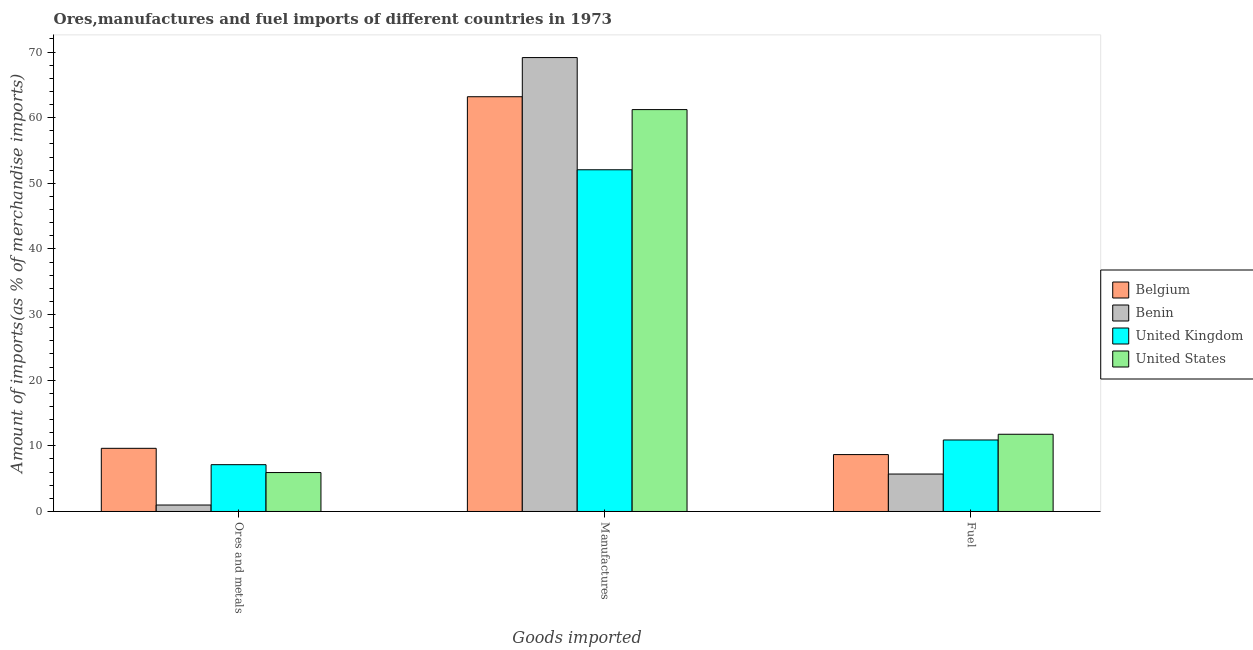How many groups of bars are there?
Offer a very short reply. 3. Are the number of bars on each tick of the X-axis equal?
Make the answer very short. Yes. How many bars are there on the 1st tick from the left?
Offer a terse response. 4. What is the label of the 3rd group of bars from the left?
Keep it short and to the point. Fuel. What is the percentage of fuel imports in United States?
Provide a short and direct response. 11.76. Across all countries, what is the maximum percentage of manufactures imports?
Your answer should be very brief. 69.15. Across all countries, what is the minimum percentage of manufactures imports?
Ensure brevity in your answer.  52.06. In which country was the percentage of fuel imports maximum?
Provide a short and direct response. United States. In which country was the percentage of fuel imports minimum?
Keep it short and to the point. Benin. What is the total percentage of manufactures imports in the graph?
Offer a terse response. 245.62. What is the difference between the percentage of manufactures imports in United Kingdom and that in United States?
Your answer should be compact. -9.17. What is the difference between the percentage of ores and metals imports in United States and the percentage of fuel imports in United Kingdom?
Give a very brief answer. -4.96. What is the average percentage of fuel imports per country?
Provide a succinct answer. 9.26. What is the difference between the percentage of ores and metals imports and percentage of fuel imports in Belgium?
Provide a short and direct response. 0.96. In how many countries, is the percentage of manufactures imports greater than 60 %?
Make the answer very short. 3. What is the ratio of the percentage of manufactures imports in United Kingdom to that in Belgium?
Your response must be concise. 0.82. Is the difference between the percentage of manufactures imports in Benin and Belgium greater than the difference between the percentage of fuel imports in Benin and Belgium?
Give a very brief answer. Yes. What is the difference between the highest and the second highest percentage of fuel imports?
Give a very brief answer. 0.87. What is the difference between the highest and the lowest percentage of ores and metals imports?
Provide a short and direct response. 8.64. What does the 1st bar from the left in Manufactures represents?
Offer a terse response. Belgium. What does the 4th bar from the right in Ores and metals represents?
Provide a succinct answer. Belgium. Is it the case that in every country, the sum of the percentage of ores and metals imports and percentage of manufactures imports is greater than the percentage of fuel imports?
Your answer should be very brief. Yes. How many bars are there?
Make the answer very short. 12. What is the difference between two consecutive major ticks on the Y-axis?
Offer a terse response. 10. Are the values on the major ticks of Y-axis written in scientific E-notation?
Provide a succinct answer. No. Where does the legend appear in the graph?
Give a very brief answer. Center right. How many legend labels are there?
Provide a succinct answer. 4. How are the legend labels stacked?
Provide a short and direct response. Vertical. What is the title of the graph?
Your answer should be very brief. Ores,manufactures and fuel imports of different countries in 1973. What is the label or title of the X-axis?
Provide a short and direct response. Goods imported. What is the label or title of the Y-axis?
Your response must be concise. Amount of imports(as % of merchandise imports). What is the Amount of imports(as % of merchandise imports) in Belgium in Ores and metals?
Your answer should be very brief. 9.62. What is the Amount of imports(as % of merchandise imports) in Benin in Ores and metals?
Provide a succinct answer. 0.98. What is the Amount of imports(as % of merchandise imports) in United Kingdom in Ores and metals?
Provide a short and direct response. 7.13. What is the Amount of imports(as % of merchandise imports) of United States in Ores and metals?
Give a very brief answer. 5.93. What is the Amount of imports(as % of merchandise imports) in Belgium in Manufactures?
Your answer should be very brief. 63.19. What is the Amount of imports(as % of merchandise imports) of Benin in Manufactures?
Keep it short and to the point. 69.15. What is the Amount of imports(as % of merchandise imports) in United Kingdom in Manufactures?
Provide a succinct answer. 52.06. What is the Amount of imports(as % of merchandise imports) of United States in Manufactures?
Keep it short and to the point. 61.23. What is the Amount of imports(as % of merchandise imports) of Belgium in Fuel?
Ensure brevity in your answer.  8.67. What is the Amount of imports(as % of merchandise imports) in Benin in Fuel?
Your response must be concise. 5.7. What is the Amount of imports(as % of merchandise imports) in United Kingdom in Fuel?
Make the answer very short. 10.89. What is the Amount of imports(as % of merchandise imports) of United States in Fuel?
Your response must be concise. 11.76. Across all Goods imported, what is the maximum Amount of imports(as % of merchandise imports) in Belgium?
Your answer should be very brief. 63.19. Across all Goods imported, what is the maximum Amount of imports(as % of merchandise imports) of Benin?
Make the answer very short. 69.15. Across all Goods imported, what is the maximum Amount of imports(as % of merchandise imports) of United Kingdom?
Your response must be concise. 52.06. Across all Goods imported, what is the maximum Amount of imports(as % of merchandise imports) of United States?
Ensure brevity in your answer.  61.23. Across all Goods imported, what is the minimum Amount of imports(as % of merchandise imports) in Belgium?
Ensure brevity in your answer.  8.67. Across all Goods imported, what is the minimum Amount of imports(as % of merchandise imports) in Benin?
Your answer should be compact. 0.98. Across all Goods imported, what is the minimum Amount of imports(as % of merchandise imports) in United Kingdom?
Your response must be concise. 7.13. Across all Goods imported, what is the minimum Amount of imports(as % of merchandise imports) of United States?
Ensure brevity in your answer.  5.93. What is the total Amount of imports(as % of merchandise imports) in Belgium in the graph?
Your answer should be compact. 81.47. What is the total Amount of imports(as % of merchandise imports) in Benin in the graph?
Your response must be concise. 75.84. What is the total Amount of imports(as % of merchandise imports) of United Kingdom in the graph?
Your response must be concise. 70.08. What is the total Amount of imports(as % of merchandise imports) of United States in the graph?
Offer a terse response. 78.92. What is the difference between the Amount of imports(as % of merchandise imports) of Belgium in Ores and metals and that in Manufactures?
Offer a very short reply. -53.56. What is the difference between the Amount of imports(as % of merchandise imports) of Benin in Ores and metals and that in Manufactures?
Provide a succinct answer. -68.17. What is the difference between the Amount of imports(as % of merchandise imports) of United Kingdom in Ores and metals and that in Manufactures?
Make the answer very short. -44.93. What is the difference between the Amount of imports(as % of merchandise imports) in United States in Ores and metals and that in Manufactures?
Provide a short and direct response. -55.29. What is the difference between the Amount of imports(as % of merchandise imports) of Belgium in Ores and metals and that in Fuel?
Offer a terse response. 0.96. What is the difference between the Amount of imports(as % of merchandise imports) in Benin in Ores and metals and that in Fuel?
Provide a short and direct response. -4.72. What is the difference between the Amount of imports(as % of merchandise imports) in United Kingdom in Ores and metals and that in Fuel?
Your answer should be compact. -3.77. What is the difference between the Amount of imports(as % of merchandise imports) of United States in Ores and metals and that in Fuel?
Make the answer very short. -5.83. What is the difference between the Amount of imports(as % of merchandise imports) of Belgium in Manufactures and that in Fuel?
Give a very brief answer. 54.52. What is the difference between the Amount of imports(as % of merchandise imports) of Benin in Manufactures and that in Fuel?
Your answer should be very brief. 63.45. What is the difference between the Amount of imports(as % of merchandise imports) of United Kingdom in Manufactures and that in Fuel?
Offer a very short reply. 41.16. What is the difference between the Amount of imports(as % of merchandise imports) of United States in Manufactures and that in Fuel?
Keep it short and to the point. 49.46. What is the difference between the Amount of imports(as % of merchandise imports) in Belgium in Ores and metals and the Amount of imports(as % of merchandise imports) in Benin in Manufactures?
Keep it short and to the point. -59.53. What is the difference between the Amount of imports(as % of merchandise imports) in Belgium in Ores and metals and the Amount of imports(as % of merchandise imports) in United Kingdom in Manufactures?
Ensure brevity in your answer.  -42.44. What is the difference between the Amount of imports(as % of merchandise imports) in Belgium in Ores and metals and the Amount of imports(as % of merchandise imports) in United States in Manufactures?
Provide a short and direct response. -51.6. What is the difference between the Amount of imports(as % of merchandise imports) of Benin in Ores and metals and the Amount of imports(as % of merchandise imports) of United Kingdom in Manufactures?
Your answer should be compact. -51.08. What is the difference between the Amount of imports(as % of merchandise imports) in Benin in Ores and metals and the Amount of imports(as % of merchandise imports) in United States in Manufactures?
Keep it short and to the point. -60.24. What is the difference between the Amount of imports(as % of merchandise imports) of United Kingdom in Ores and metals and the Amount of imports(as % of merchandise imports) of United States in Manufactures?
Give a very brief answer. -54.1. What is the difference between the Amount of imports(as % of merchandise imports) in Belgium in Ores and metals and the Amount of imports(as % of merchandise imports) in Benin in Fuel?
Offer a very short reply. 3.92. What is the difference between the Amount of imports(as % of merchandise imports) of Belgium in Ores and metals and the Amount of imports(as % of merchandise imports) of United Kingdom in Fuel?
Make the answer very short. -1.27. What is the difference between the Amount of imports(as % of merchandise imports) of Belgium in Ores and metals and the Amount of imports(as % of merchandise imports) of United States in Fuel?
Offer a very short reply. -2.14. What is the difference between the Amount of imports(as % of merchandise imports) in Benin in Ores and metals and the Amount of imports(as % of merchandise imports) in United Kingdom in Fuel?
Your answer should be very brief. -9.91. What is the difference between the Amount of imports(as % of merchandise imports) in Benin in Ores and metals and the Amount of imports(as % of merchandise imports) in United States in Fuel?
Keep it short and to the point. -10.78. What is the difference between the Amount of imports(as % of merchandise imports) of United Kingdom in Ores and metals and the Amount of imports(as % of merchandise imports) of United States in Fuel?
Your answer should be compact. -4.64. What is the difference between the Amount of imports(as % of merchandise imports) of Belgium in Manufactures and the Amount of imports(as % of merchandise imports) of Benin in Fuel?
Provide a succinct answer. 57.48. What is the difference between the Amount of imports(as % of merchandise imports) of Belgium in Manufactures and the Amount of imports(as % of merchandise imports) of United Kingdom in Fuel?
Provide a short and direct response. 52.29. What is the difference between the Amount of imports(as % of merchandise imports) of Belgium in Manufactures and the Amount of imports(as % of merchandise imports) of United States in Fuel?
Offer a very short reply. 51.42. What is the difference between the Amount of imports(as % of merchandise imports) of Benin in Manufactures and the Amount of imports(as % of merchandise imports) of United Kingdom in Fuel?
Provide a succinct answer. 58.26. What is the difference between the Amount of imports(as % of merchandise imports) in Benin in Manufactures and the Amount of imports(as % of merchandise imports) in United States in Fuel?
Your response must be concise. 57.39. What is the difference between the Amount of imports(as % of merchandise imports) in United Kingdom in Manufactures and the Amount of imports(as % of merchandise imports) in United States in Fuel?
Give a very brief answer. 40.29. What is the average Amount of imports(as % of merchandise imports) in Belgium per Goods imported?
Provide a short and direct response. 27.16. What is the average Amount of imports(as % of merchandise imports) in Benin per Goods imported?
Your answer should be compact. 25.28. What is the average Amount of imports(as % of merchandise imports) of United Kingdom per Goods imported?
Keep it short and to the point. 23.36. What is the average Amount of imports(as % of merchandise imports) of United States per Goods imported?
Your answer should be compact. 26.31. What is the difference between the Amount of imports(as % of merchandise imports) of Belgium and Amount of imports(as % of merchandise imports) of Benin in Ores and metals?
Offer a terse response. 8.64. What is the difference between the Amount of imports(as % of merchandise imports) in Belgium and Amount of imports(as % of merchandise imports) in United Kingdom in Ores and metals?
Offer a terse response. 2.49. What is the difference between the Amount of imports(as % of merchandise imports) of Belgium and Amount of imports(as % of merchandise imports) of United States in Ores and metals?
Your answer should be compact. 3.69. What is the difference between the Amount of imports(as % of merchandise imports) of Benin and Amount of imports(as % of merchandise imports) of United Kingdom in Ores and metals?
Offer a very short reply. -6.15. What is the difference between the Amount of imports(as % of merchandise imports) of Benin and Amount of imports(as % of merchandise imports) of United States in Ores and metals?
Give a very brief answer. -4.95. What is the difference between the Amount of imports(as % of merchandise imports) in United Kingdom and Amount of imports(as % of merchandise imports) in United States in Ores and metals?
Make the answer very short. 1.2. What is the difference between the Amount of imports(as % of merchandise imports) of Belgium and Amount of imports(as % of merchandise imports) of Benin in Manufactures?
Make the answer very short. -5.97. What is the difference between the Amount of imports(as % of merchandise imports) in Belgium and Amount of imports(as % of merchandise imports) in United Kingdom in Manufactures?
Offer a terse response. 11.13. What is the difference between the Amount of imports(as % of merchandise imports) of Belgium and Amount of imports(as % of merchandise imports) of United States in Manufactures?
Make the answer very short. 1.96. What is the difference between the Amount of imports(as % of merchandise imports) in Benin and Amount of imports(as % of merchandise imports) in United Kingdom in Manufactures?
Make the answer very short. 17.09. What is the difference between the Amount of imports(as % of merchandise imports) in Benin and Amount of imports(as % of merchandise imports) in United States in Manufactures?
Your answer should be compact. 7.93. What is the difference between the Amount of imports(as % of merchandise imports) of United Kingdom and Amount of imports(as % of merchandise imports) of United States in Manufactures?
Your response must be concise. -9.17. What is the difference between the Amount of imports(as % of merchandise imports) in Belgium and Amount of imports(as % of merchandise imports) in Benin in Fuel?
Keep it short and to the point. 2.96. What is the difference between the Amount of imports(as % of merchandise imports) in Belgium and Amount of imports(as % of merchandise imports) in United Kingdom in Fuel?
Provide a succinct answer. -2.23. What is the difference between the Amount of imports(as % of merchandise imports) of Belgium and Amount of imports(as % of merchandise imports) of United States in Fuel?
Make the answer very short. -3.1. What is the difference between the Amount of imports(as % of merchandise imports) of Benin and Amount of imports(as % of merchandise imports) of United Kingdom in Fuel?
Make the answer very short. -5.19. What is the difference between the Amount of imports(as % of merchandise imports) in Benin and Amount of imports(as % of merchandise imports) in United States in Fuel?
Your answer should be compact. -6.06. What is the difference between the Amount of imports(as % of merchandise imports) in United Kingdom and Amount of imports(as % of merchandise imports) in United States in Fuel?
Offer a terse response. -0.87. What is the ratio of the Amount of imports(as % of merchandise imports) of Belgium in Ores and metals to that in Manufactures?
Make the answer very short. 0.15. What is the ratio of the Amount of imports(as % of merchandise imports) of Benin in Ores and metals to that in Manufactures?
Offer a terse response. 0.01. What is the ratio of the Amount of imports(as % of merchandise imports) of United Kingdom in Ores and metals to that in Manufactures?
Your response must be concise. 0.14. What is the ratio of the Amount of imports(as % of merchandise imports) in United States in Ores and metals to that in Manufactures?
Your answer should be very brief. 0.1. What is the ratio of the Amount of imports(as % of merchandise imports) of Belgium in Ores and metals to that in Fuel?
Ensure brevity in your answer.  1.11. What is the ratio of the Amount of imports(as % of merchandise imports) in Benin in Ores and metals to that in Fuel?
Give a very brief answer. 0.17. What is the ratio of the Amount of imports(as % of merchandise imports) in United Kingdom in Ores and metals to that in Fuel?
Offer a terse response. 0.65. What is the ratio of the Amount of imports(as % of merchandise imports) in United States in Ores and metals to that in Fuel?
Ensure brevity in your answer.  0.5. What is the ratio of the Amount of imports(as % of merchandise imports) of Belgium in Manufactures to that in Fuel?
Provide a short and direct response. 7.29. What is the ratio of the Amount of imports(as % of merchandise imports) of Benin in Manufactures to that in Fuel?
Your answer should be compact. 12.12. What is the ratio of the Amount of imports(as % of merchandise imports) in United Kingdom in Manufactures to that in Fuel?
Your response must be concise. 4.78. What is the ratio of the Amount of imports(as % of merchandise imports) in United States in Manufactures to that in Fuel?
Keep it short and to the point. 5.2. What is the difference between the highest and the second highest Amount of imports(as % of merchandise imports) in Belgium?
Give a very brief answer. 53.56. What is the difference between the highest and the second highest Amount of imports(as % of merchandise imports) of Benin?
Your answer should be very brief. 63.45. What is the difference between the highest and the second highest Amount of imports(as % of merchandise imports) of United Kingdom?
Give a very brief answer. 41.16. What is the difference between the highest and the second highest Amount of imports(as % of merchandise imports) in United States?
Ensure brevity in your answer.  49.46. What is the difference between the highest and the lowest Amount of imports(as % of merchandise imports) of Belgium?
Keep it short and to the point. 54.52. What is the difference between the highest and the lowest Amount of imports(as % of merchandise imports) in Benin?
Provide a short and direct response. 68.17. What is the difference between the highest and the lowest Amount of imports(as % of merchandise imports) in United Kingdom?
Your response must be concise. 44.93. What is the difference between the highest and the lowest Amount of imports(as % of merchandise imports) of United States?
Offer a terse response. 55.29. 